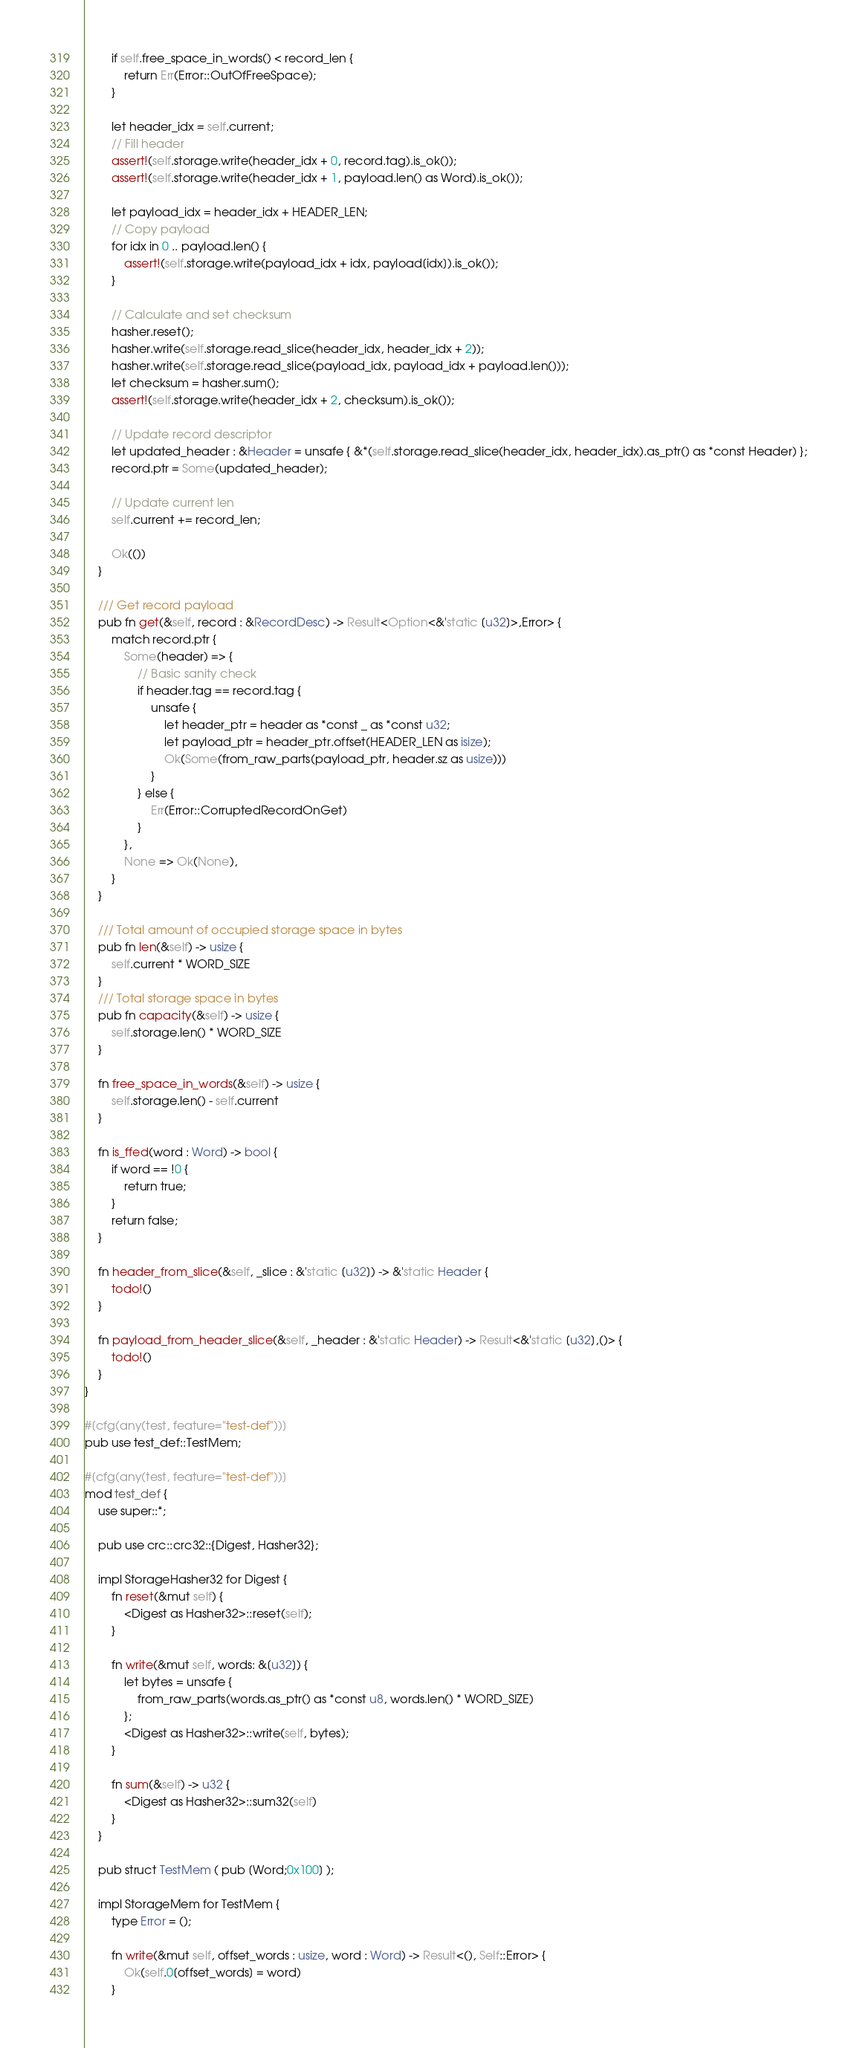Convert code to text. <code><loc_0><loc_0><loc_500><loc_500><_Rust_>        if self.free_space_in_words() < record_len {
            return Err(Error::OutOfFreeSpace);
        }

        let header_idx = self.current;
        // Fill header
        assert!(self.storage.write(header_idx + 0, record.tag).is_ok());
        assert!(self.storage.write(header_idx + 1, payload.len() as Word).is_ok());

        let payload_idx = header_idx + HEADER_LEN;
        // Copy payload
        for idx in 0 .. payload.len() {
            assert!(self.storage.write(payload_idx + idx, payload[idx]).is_ok());
        }
        
        // Calculate and set checksum
        hasher.reset();
        hasher.write(self.storage.read_slice(header_idx, header_idx + 2));
        hasher.write(self.storage.read_slice(payload_idx, payload_idx + payload.len()));
        let checksum = hasher.sum();
        assert!(self.storage.write(header_idx + 2, checksum).is_ok());

        // Update record descriptor
        let updated_header : &Header = unsafe { &*(self.storage.read_slice(header_idx, header_idx).as_ptr() as *const Header) };
        record.ptr = Some(updated_header);

        // Update current len
        self.current += record_len;

        Ok(())
    }
    
    /// Get record payload
    pub fn get(&self, record : &RecordDesc) -> Result<Option<&'static [u32]>,Error> {
        match record.ptr {
            Some(header) => {
                // Basic sanity check
                if header.tag == record.tag {
                    unsafe {
                        let header_ptr = header as *const _ as *const u32;
                        let payload_ptr = header_ptr.offset(HEADER_LEN as isize);
                        Ok(Some(from_raw_parts(payload_ptr, header.sz as usize)))
                    }
                } else {
                    Err(Error::CorruptedRecordOnGet)
                }
            },
            None => Ok(None),
        }
    }

    /// Total amount of occupied storage space in bytes
    pub fn len(&self) -> usize {
        self.current * WORD_SIZE
    }
    /// Total storage space in bytes
    pub fn capacity(&self) -> usize {
        self.storage.len() * WORD_SIZE
    }

    fn free_space_in_words(&self) -> usize {
        self.storage.len() - self.current
    }

    fn is_ffed(word : Word) -> bool {
        if word == !0 {
            return true;
        }
        return false;
    }

    fn header_from_slice(&self, _slice : &'static [u32]) -> &'static Header {
        todo!()
    }

    fn payload_from_header_slice(&self, _header : &'static Header) -> Result<&'static [u32],()> {
        todo!()
    }
}

#[cfg(any(test, feature="test-def"))]
pub use test_def::TestMem;

#[cfg(any(test, feature="test-def"))]
mod test_def {
    use super::*;

    pub use crc::crc32::{Digest, Hasher32};

    impl StorageHasher32 for Digest {
        fn reset(&mut self) {
            <Digest as Hasher32>::reset(self);
        }

        fn write(&mut self, words: &[u32]) {
            let bytes = unsafe { 
                from_raw_parts(words.as_ptr() as *const u8, words.len() * WORD_SIZE) 
            };
            <Digest as Hasher32>::write(self, bytes);
        }

        fn sum(&self) -> u32 {
            <Digest as Hasher32>::sum32(self)
        }
    }

    pub struct TestMem ( pub [Word;0x100] );

    impl StorageMem for TestMem {
        type Error = ();

        fn write(&mut self, offset_words : usize, word : Word) -> Result<(), Self::Error> {
            Ok(self.0[offset_words] = word)
        }
</code> 